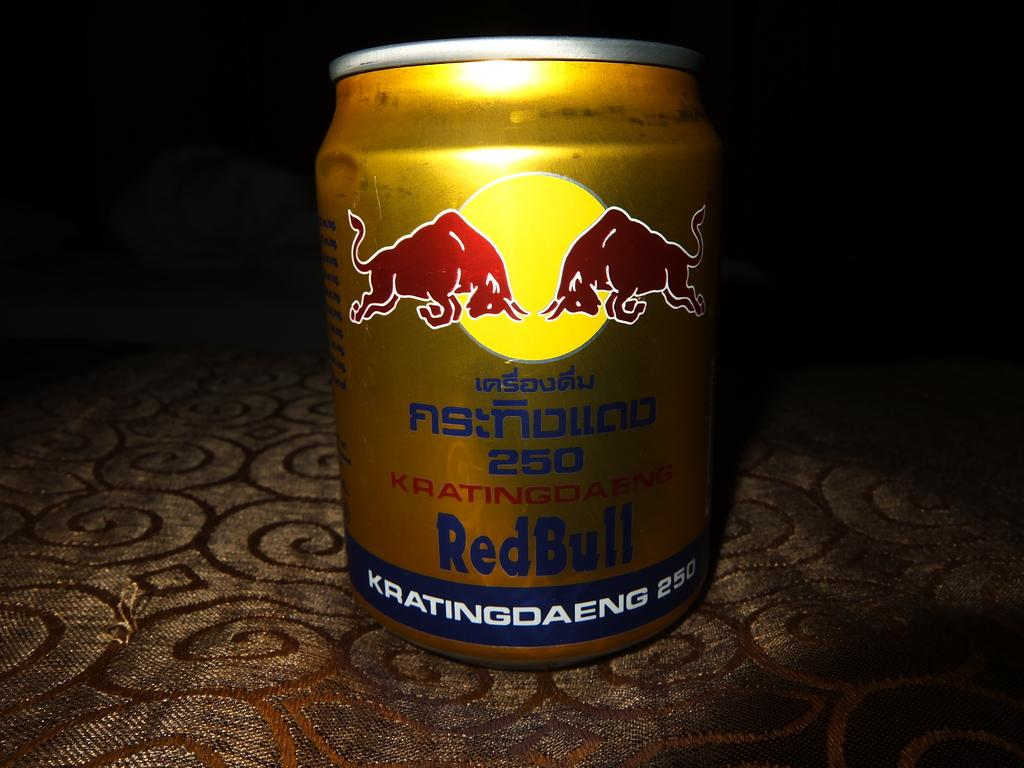Provide a one-sentence caption for the provided image. a red bull container that is on a surface. 